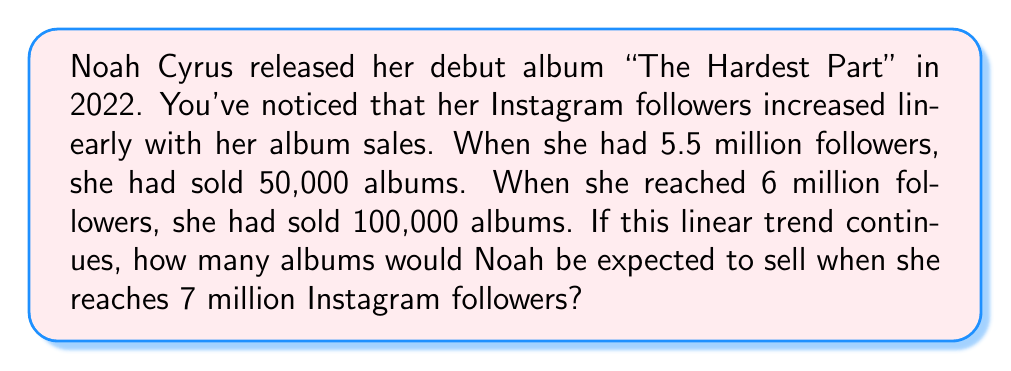Show me your answer to this math problem. Let's approach this step-by-step using a linear equation:

1) First, we need to find the slope (m) of the line. The slope represents the rate of change in album sales per follower.

   $m = \frac{y_2 - y_1}{x_2 - x_1} = \frac{100,000 - 50,000}{6,000,000 - 5,500,000} = \frac{50,000}{500,000} = 0.1$

2) Now we can use the point-slope form of a linear equation:
   $y - y_1 = m(x - x_1)$

   Let's use the point (5,500,000, 50,000) as our $(x_1, y_1)$

3) Substituting our values:
   $y - 50,000 = 0.1(x - 5,500,000)$

4) Simplify:
   $y = 0.1x - 550,000 + 50,000$
   $y = 0.1x - 500,000$

5) This is our equation relating followers (x) to album sales (y).

6) To find the expected sales at 7 million followers, we substitute x = 7,000,000:

   $y = 0.1(7,000,000) - 500,000$
   $y = 700,000 - 500,000$
   $y = 200,000$

Therefore, if the trend continues, Noah would be expected to sell 200,000 albums when she reaches 7 million Instagram followers.
Answer: 200,000 albums 